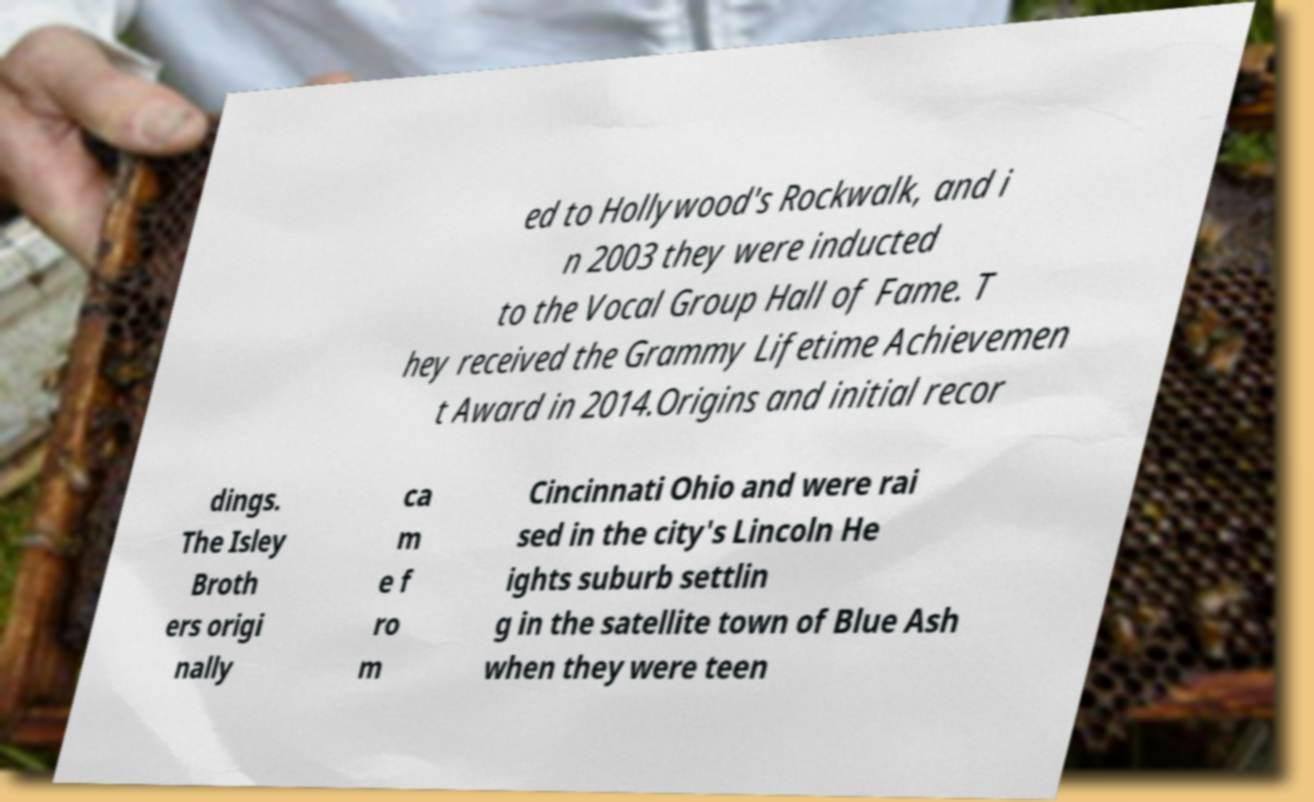Please identify and transcribe the text found in this image. ed to Hollywood's Rockwalk, and i n 2003 they were inducted to the Vocal Group Hall of Fame. T hey received the Grammy Lifetime Achievemen t Award in 2014.Origins and initial recor dings. The Isley Broth ers origi nally ca m e f ro m Cincinnati Ohio and were rai sed in the city's Lincoln He ights suburb settlin g in the satellite town of Blue Ash when they were teen 